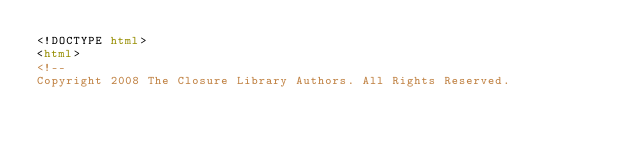<code> <loc_0><loc_0><loc_500><loc_500><_HTML_><!DOCTYPE html>
<html>
<!--
Copyright 2008 The Closure Library Authors. All Rights Reserved.
</code> 